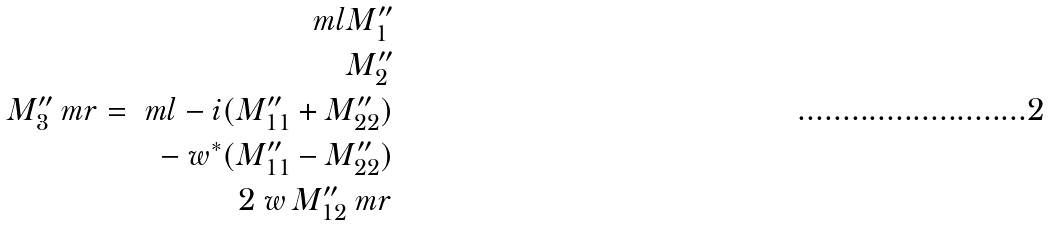<formula> <loc_0><loc_0><loc_500><loc_500>\ m l M ^ { \prime \prime } _ { 1 } \\ M ^ { \prime \prime } _ { 2 } \\ M ^ { \prime \prime } _ { 3 } \ m r = \ m l - i ( M ^ { \prime \prime } _ { 1 1 } + M ^ { \prime \prime } _ { 2 2 } ) \\ - \ w ^ { * } ( M ^ { \prime \prime } _ { 1 1 } - M ^ { \prime \prime } _ { 2 2 } ) \\ 2 \ w \, M ^ { \prime \prime } _ { 1 2 } \ m r</formula> 